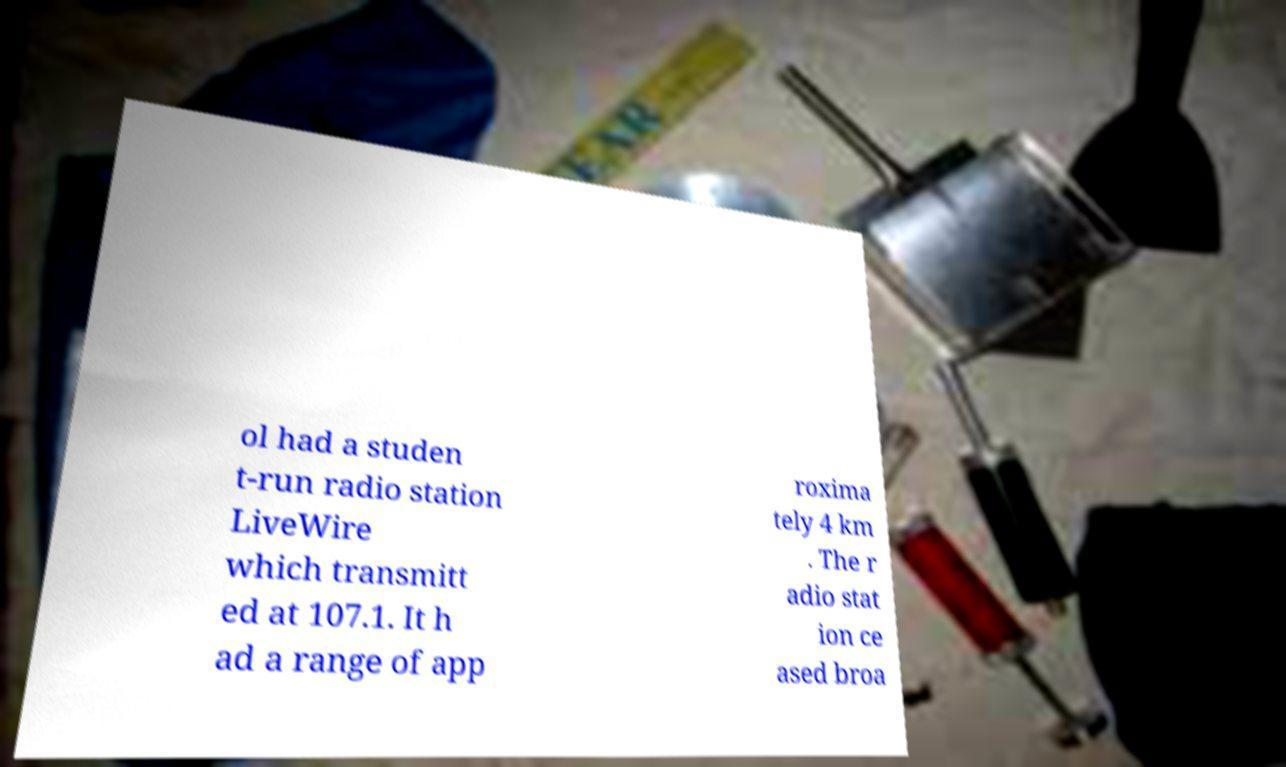Can you read and provide the text displayed in the image?This photo seems to have some interesting text. Can you extract and type it out for me? ol had a studen t-run radio station LiveWire which transmitt ed at 107.1. It h ad a range of app roxima tely 4 km . The r adio stat ion ce ased broa 